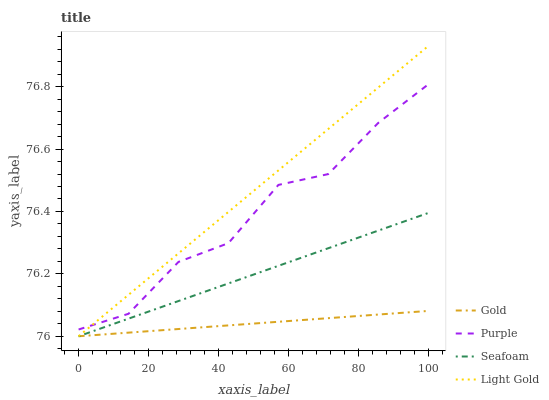Does Gold have the minimum area under the curve?
Answer yes or no. Yes. Does Light Gold have the maximum area under the curve?
Answer yes or no. Yes. Does Seafoam have the minimum area under the curve?
Answer yes or no. No. Does Seafoam have the maximum area under the curve?
Answer yes or no. No. Is Light Gold the smoothest?
Answer yes or no. Yes. Is Purple the roughest?
Answer yes or no. Yes. Is Seafoam the smoothest?
Answer yes or no. No. Is Seafoam the roughest?
Answer yes or no. No. Does Light Gold have the lowest value?
Answer yes or no. Yes. Does Light Gold have the highest value?
Answer yes or no. Yes. Does Seafoam have the highest value?
Answer yes or no. No. Is Gold less than Purple?
Answer yes or no. Yes. Is Purple greater than Gold?
Answer yes or no. Yes. Does Gold intersect Seafoam?
Answer yes or no. Yes. Is Gold less than Seafoam?
Answer yes or no. No. Is Gold greater than Seafoam?
Answer yes or no. No. Does Gold intersect Purple?
Answer yes or no. No. 